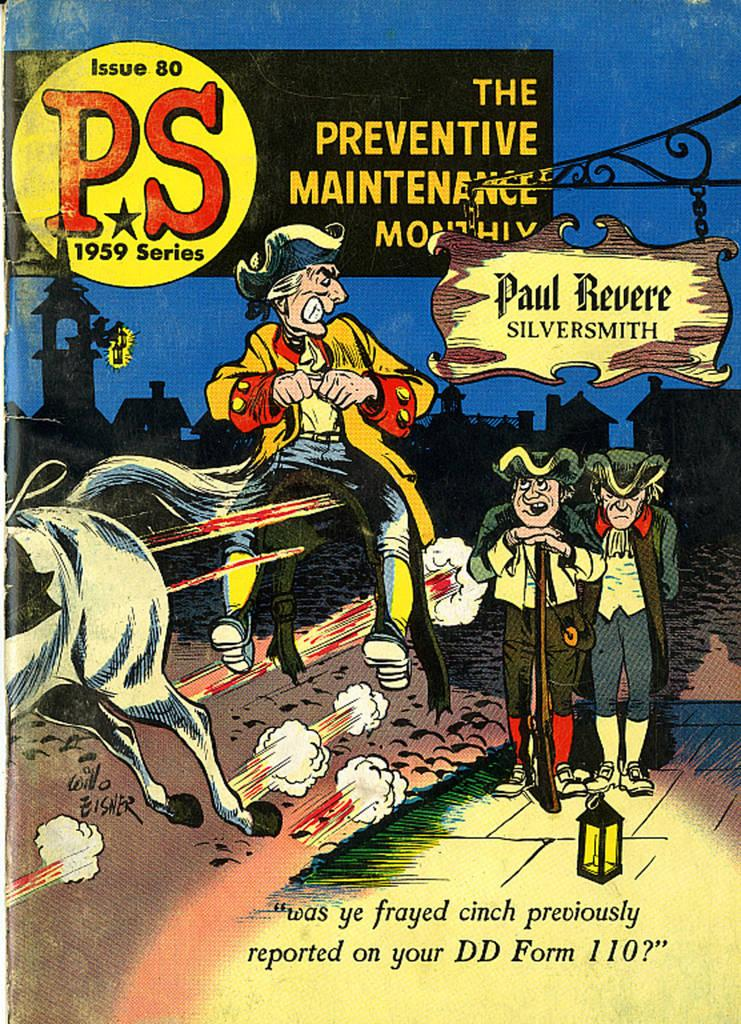<image>
Offer a succinct explanation of the picture presented. Issue 30 of The Preventive Maintenance Monthly magazine shoes men on the cover. 